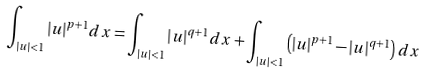Convert formula to latex. <formula><loc_0><loc_0><loc_500><loc_500>\int _ { | u | < 1 } | u | ^ { p + 1 } d x = \int _ { | u | < 1 } | u | ^ { q + 1 } d x + \int _ { | u | < 1 } \left ( | u | ^ { p + 1 } - | u | ^ { q + 1 } \right ) d x</formula> 